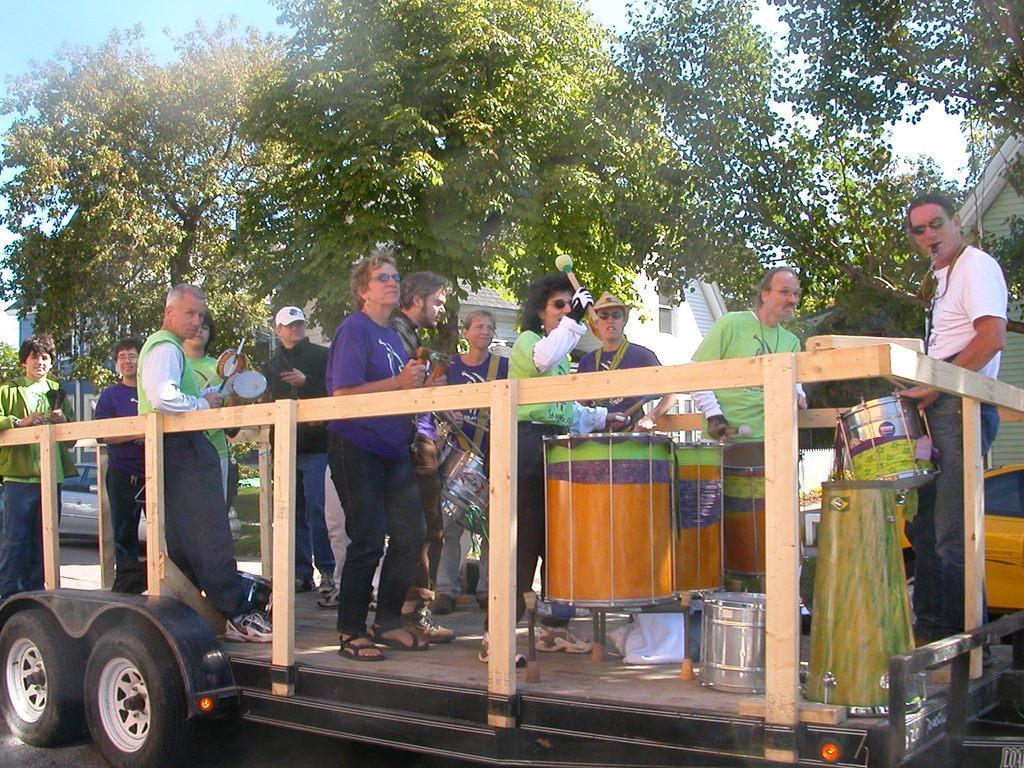What is the main subject in the middle of the image? There is a vehicle in the middle of the image. What is happening on the vehicle? Many people are on the vehicle, and there are drumsticks and musical instruments present. What can be seen in the background of the image? There are houses, trees, and the sky visible in the background of the image. What type of pump is being used to inflate the musical instruments on the vehicle? There is no pump present in the image, and the musical instruments do not require inflation. 